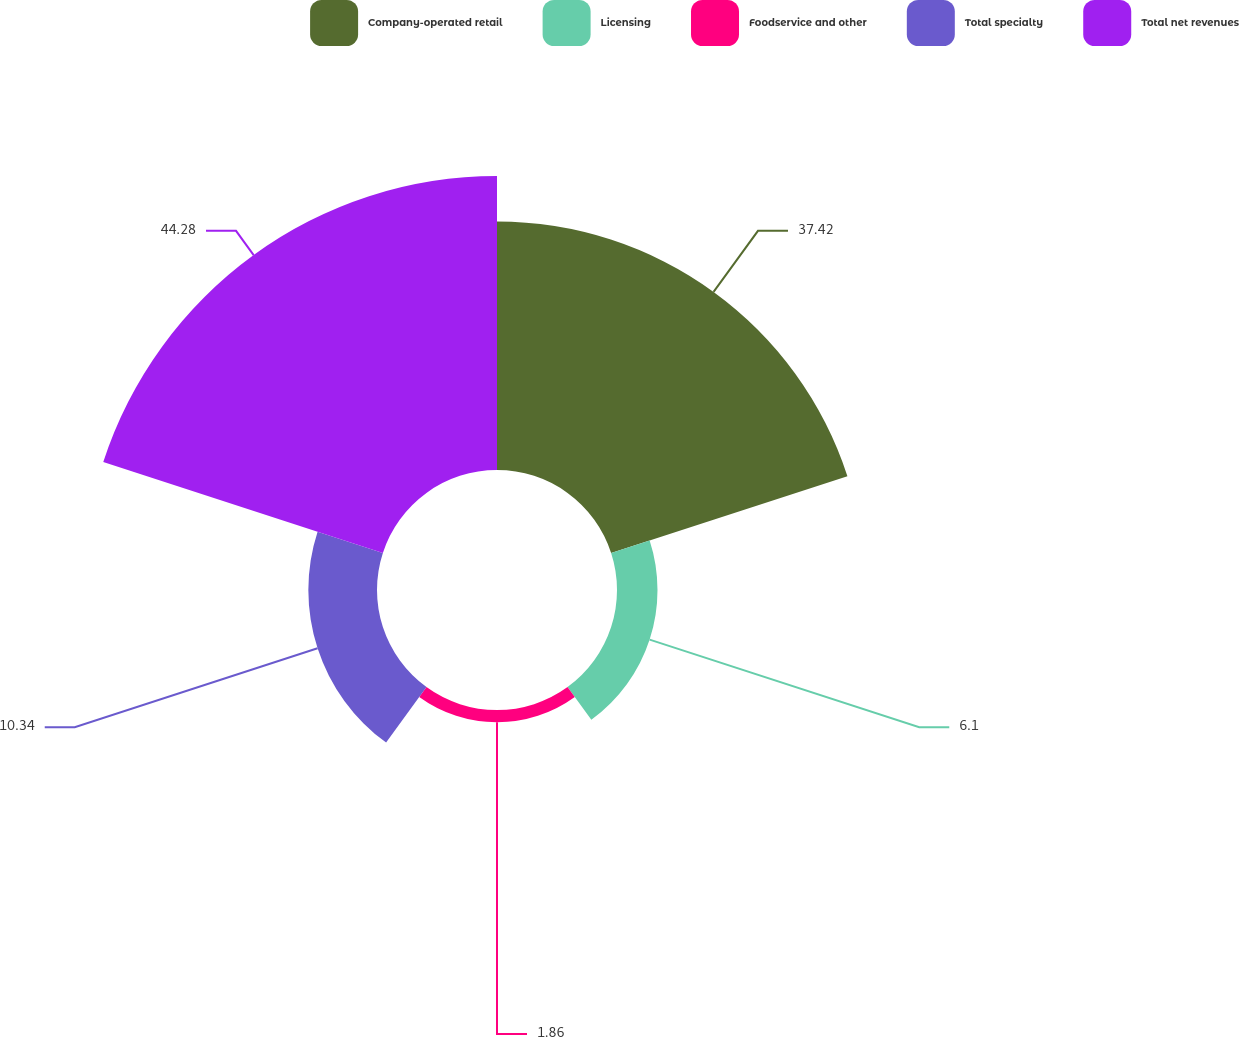<chart> <loc_0><loc_0><loc_500><loc_500><pie_chart><fcel>Company-operated retail<fcel>Licensing<fcel>Foodservice and other<fcel>Total specialty<fcel>Total net revenues<nl><fcel>37.42%<fcel>6.1%<fcel>1.86%<fcel>10.34%<fcel>44.28%<nl></chart> 